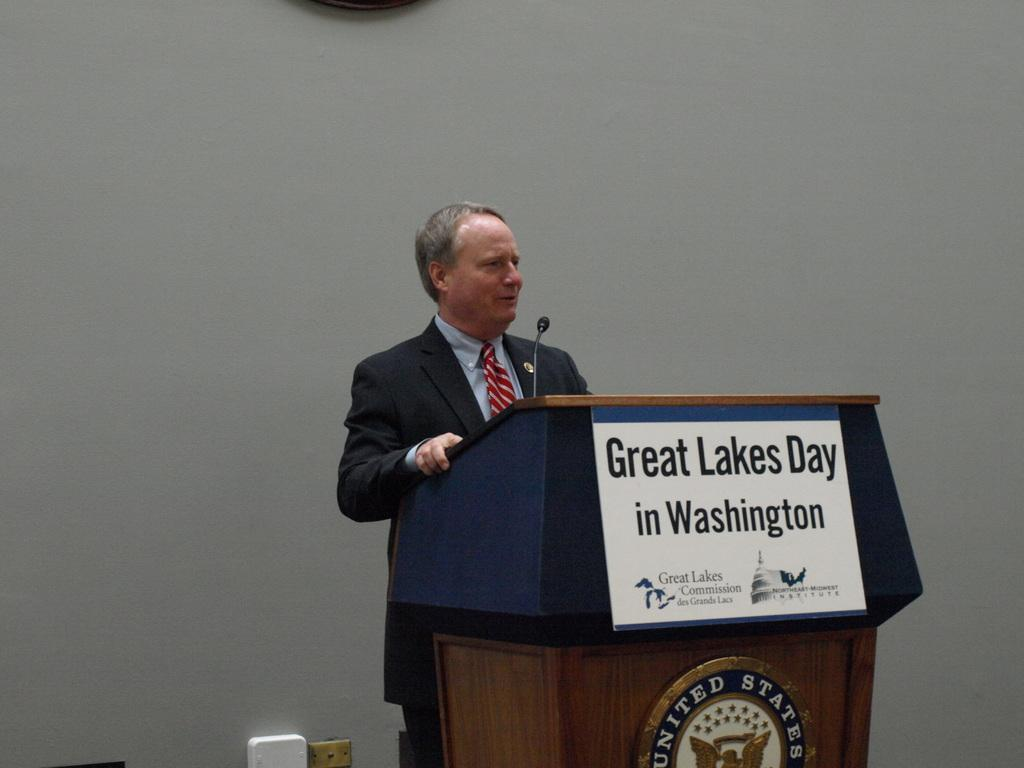<image>
Describe the image concisely. A man stands at a podium with a sign on it reading "Great Lakes Day in Washington. 